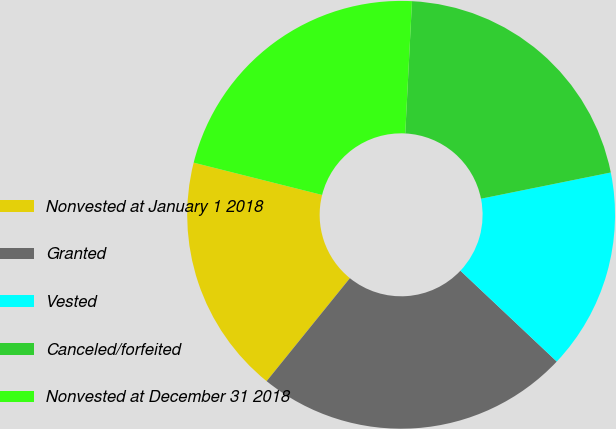<chart> <loc_0><loc_0><loc_500><loc_500><pie_chart><fcel>Nonvested at January 1 2018<fcel>Granted<fcel>Vested<fcel>Canceled/forfeited<fcel>Nonvested at December 31 2018<nl><fcel>18.1%<fcel>23.79%<fcel>15.2%<fcel>21.02%<fcel>21.89%<nl></chart> 